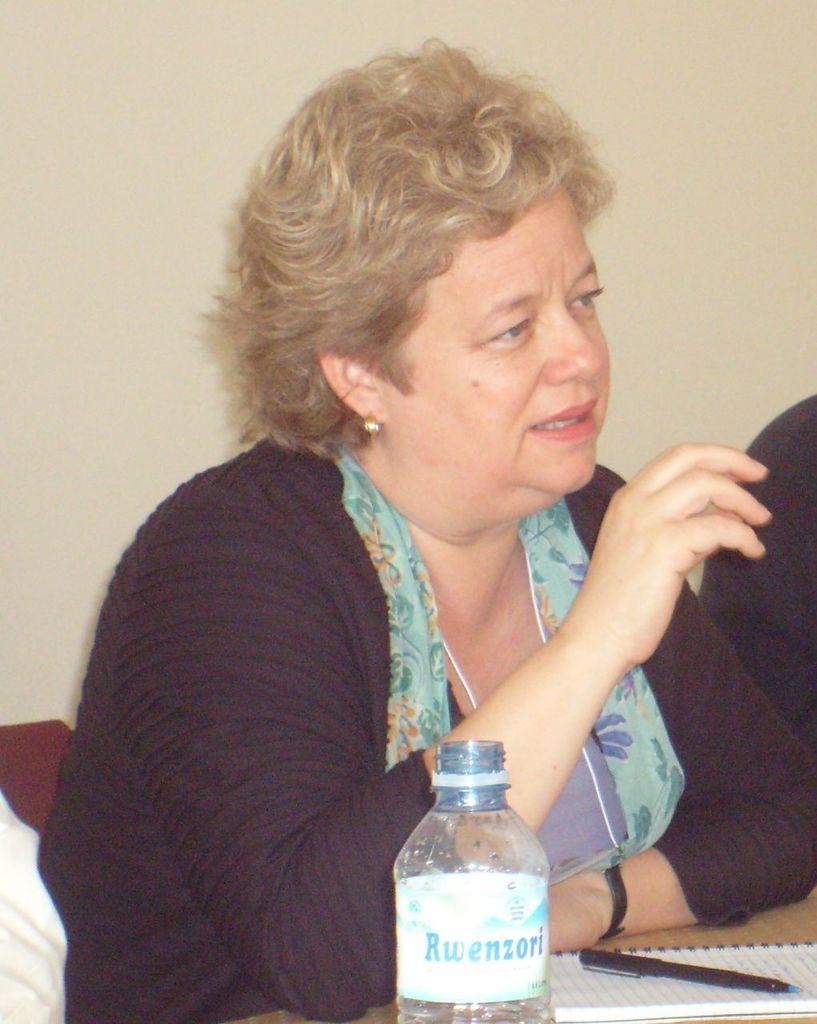How would you summarize this image in a sentence or two? This is the picture of a woman in black dress sitting on a chair. In front of the woman there is a table on the table there are bottle, book and pen. Behind the woman there is a wall. 